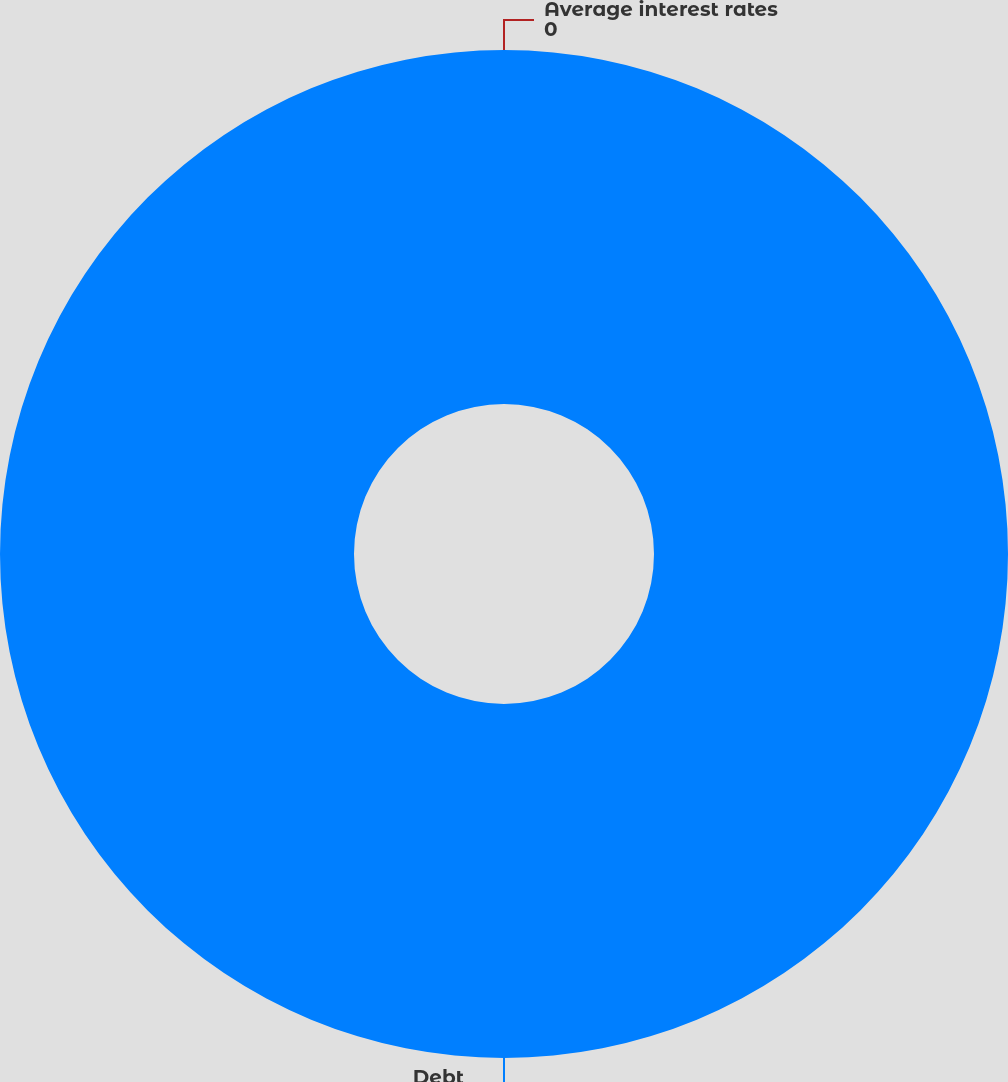<chart> <loc_0><loc_0><loc_500><loc_500><pie_chart><fcel>Debt<fcel>Average interest rates<nl><fcel>100.0%<fcel>0.0%<nl></chart> 